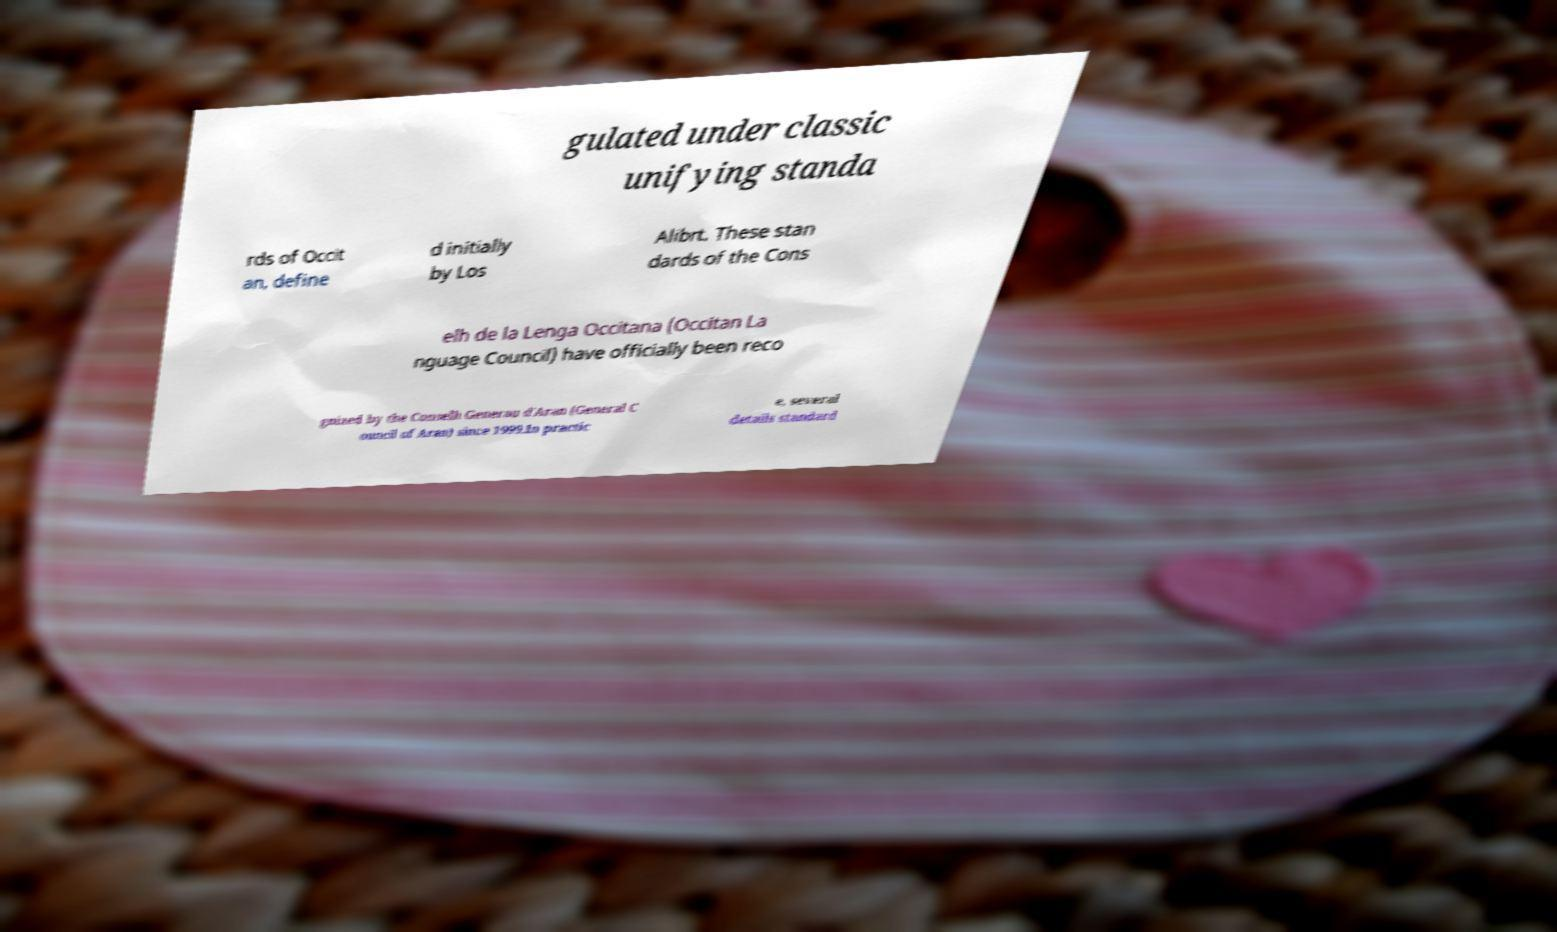I need the written content from this picture converted into text. Can you do that? gulated under classic unifying standa rds of Occit an, define d initially by Los Alibrt. These stan dards of the Cons elh de la Lenga Occitana (Occitan La nguage Council) have officially been reco gnized by the Conselh Generau d'Aran (General C ouncil of Aran) since 1999.In practic e, several details standard 